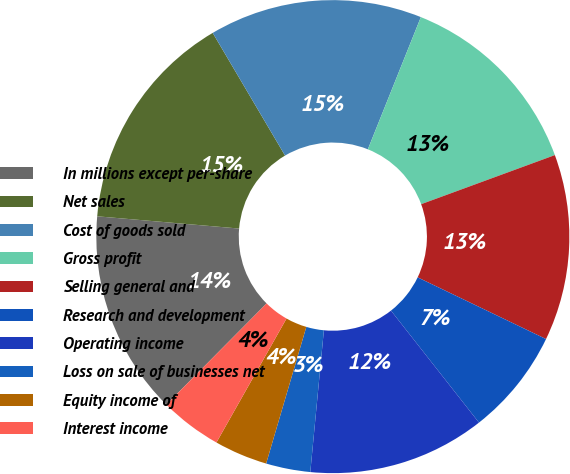Convert chart. <chart><loc_0><loc_0><loc_500><loc_500><pie_chart><fcel>In millions except per-share<fcel>Net sales<fcel>Cost of goods sold<fcel>Gross profit<fcel>Selling general and<fcel>Research and development<fcel>Operating income<fcel>Loss on sale of businesses net<fcel>Equity income of<fcel>Interest income<nl><fcel>13.94%<fcel>15.15%<fcel>14.55%<fcel>13.33%<fcel>12.73%<fcel>7.27%<fcel>12.12%<fcel>3.03%<fcel>3.64%<fcel>4.24%<nl></chart> 